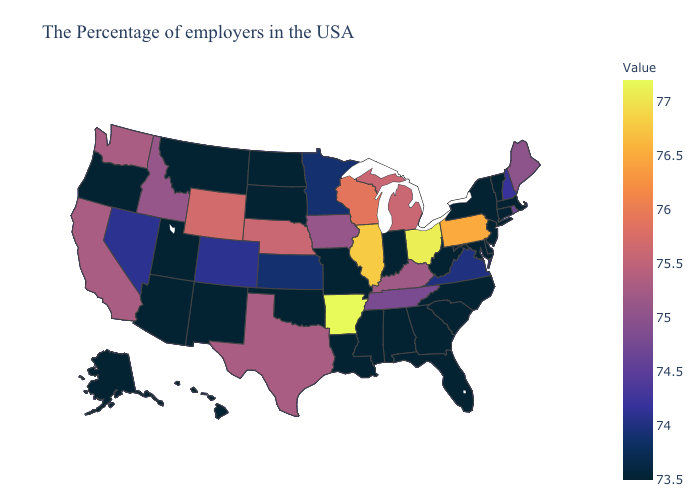Does the map have missing data?
Answer briefly. No. Among the states that border Nevada , does California have the highest value?
Write a very short answer. Yes. Does Minnesota have the lowest value in the USA?
Write a very short answer. No. Is the legend a continuous bar?
Concise answer only. Yes. Among the states that border Nevada , does California have the highest value?
Short answer required. Yes. Does Missouri have the lowest value in the MidWest?
Answer briefly. Yes. 